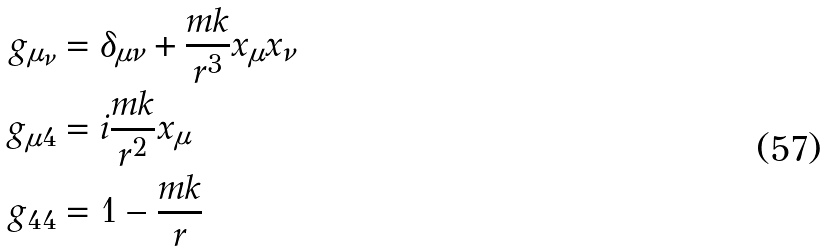Convert formula to latex. <formula><loc_0><loc_0><loc_500><loc_500>g _ { \mu _ { \nu } } & = \delta _ { \mu \nu } + \frac { m k } { r ^ { 3 } } x _ { \mu } x _ { \nu } \\ g _ { \mu 4 } & = i \frac { m k } { r ^ { 2 } } x _ { \mu } \\ g _ { 4 4 } & = 1 - \frac { m k } { r } \\ &</formula> 